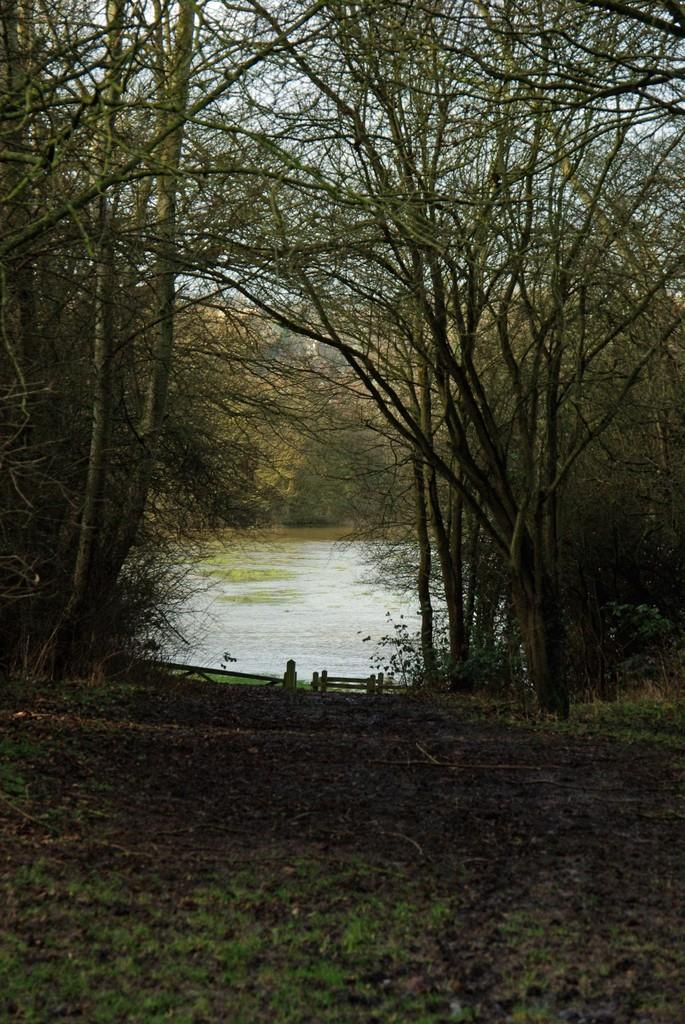What type of natural body of water is present in the image? There is a lake in the image. What type of seating is available near the lake? There is a bench on the ground in the image. What type of vegetation is present in the image? There are trees in the image. What is visible in the background of the image? The sky is visible in the background of the image. What language is the writer using to describe the scene in the image? There is no writer present in the image, so it is not possible to determine the language being used. 